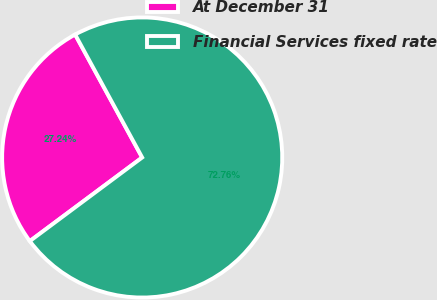<chart> <loc_0><loc_0><loc_500><loc_500><pie_chart><fcel>At December 31<fcel>Financial Services fixed rate<nl><fcel>27.24%<fcel>72.76%<nl></chart> 